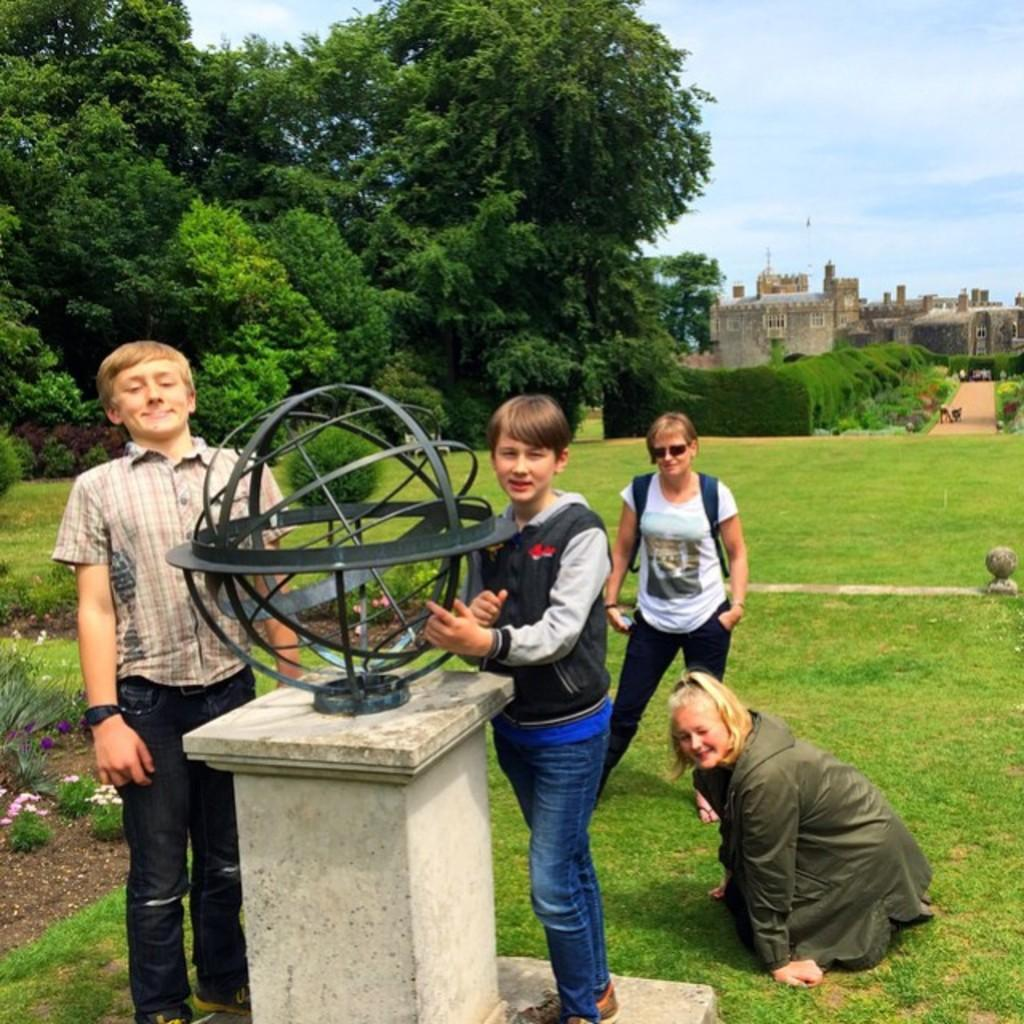How many people are present in the image? There are four persons in the image. What object can be seen in the image that represents the Earth? There is a metal globe in the image. What type of vegetation is present in the image? There are plants, flowers, and trees in the image. What type of structure can be seen in the image? There is a fort in the image. What is visible in the background of the image? The sky is visible in the background of the image. What type of milk is being served in the image? There is no milk present in the image. Can you tell me how many snakes are slithering around the fort in the image? There are no snakes present in the image; the fort is surrounded by trees and plants. 